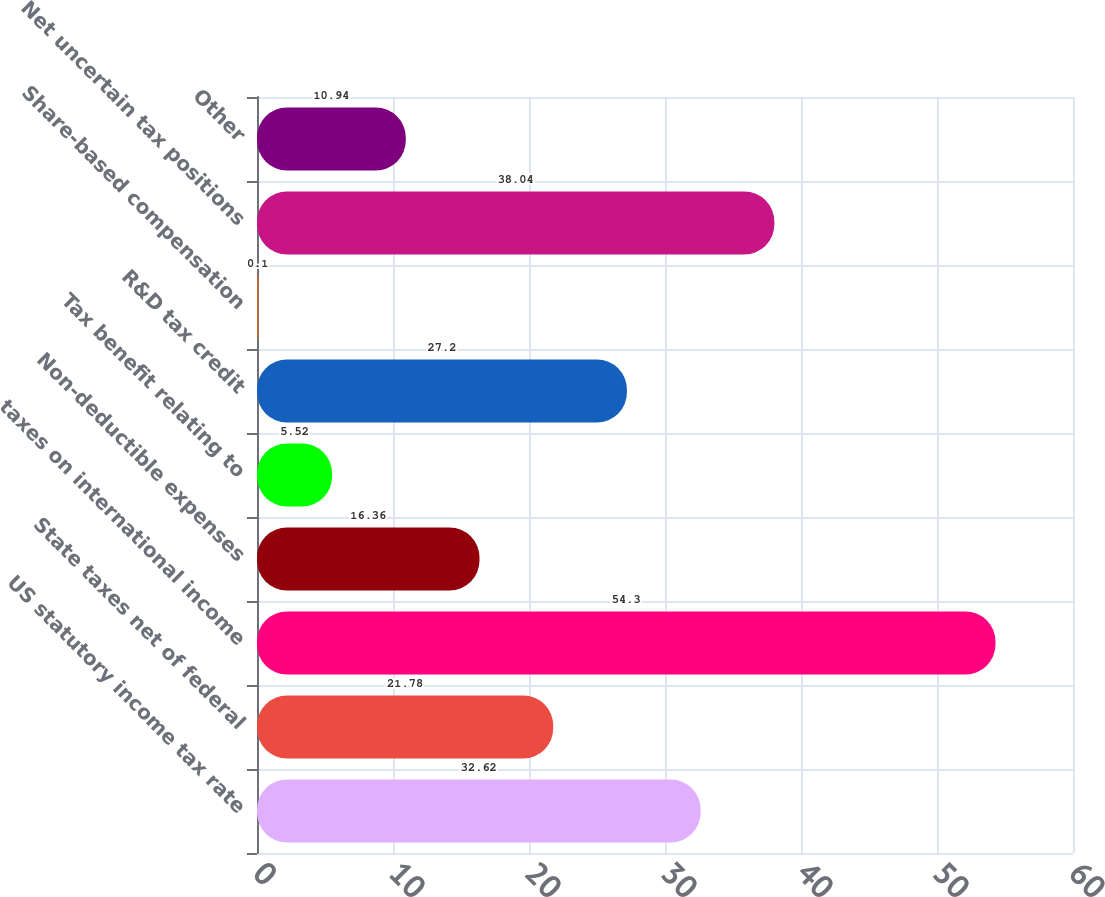Convert chart. <chart><loc_0><loc_0><loc_500><loc_500><bar_chart><fcel>US statutory income tax rate<fcel>State taxes net of federal<fcel>taxes on international income<fcel>Non-deductible expenses<fcel>Tax benefit relating to<fcel>R&D tax credit<fcel>Share-based compensation<fcel>Net uncertain tax positions<fcel>Other<nl><fcel>32.62<fcel>21.78<fcel>54.3<fcel>16.36<fcel>5.52<fcel>27.2<fcel>0.1<fcel>38.04<fcel>10.94<nl></chart> 